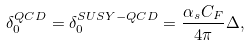Convert formula to latex. <formula><loc_0><loc_0><loc_500><loc_500>\delta _ { 0 } ^ { Q C D } = \delta _ { 0 } ^ { S U S Y - Q C D } = \frac { \alpha _ { s } C _ { F } } { 4 \pi } \Delta ,</formula> 